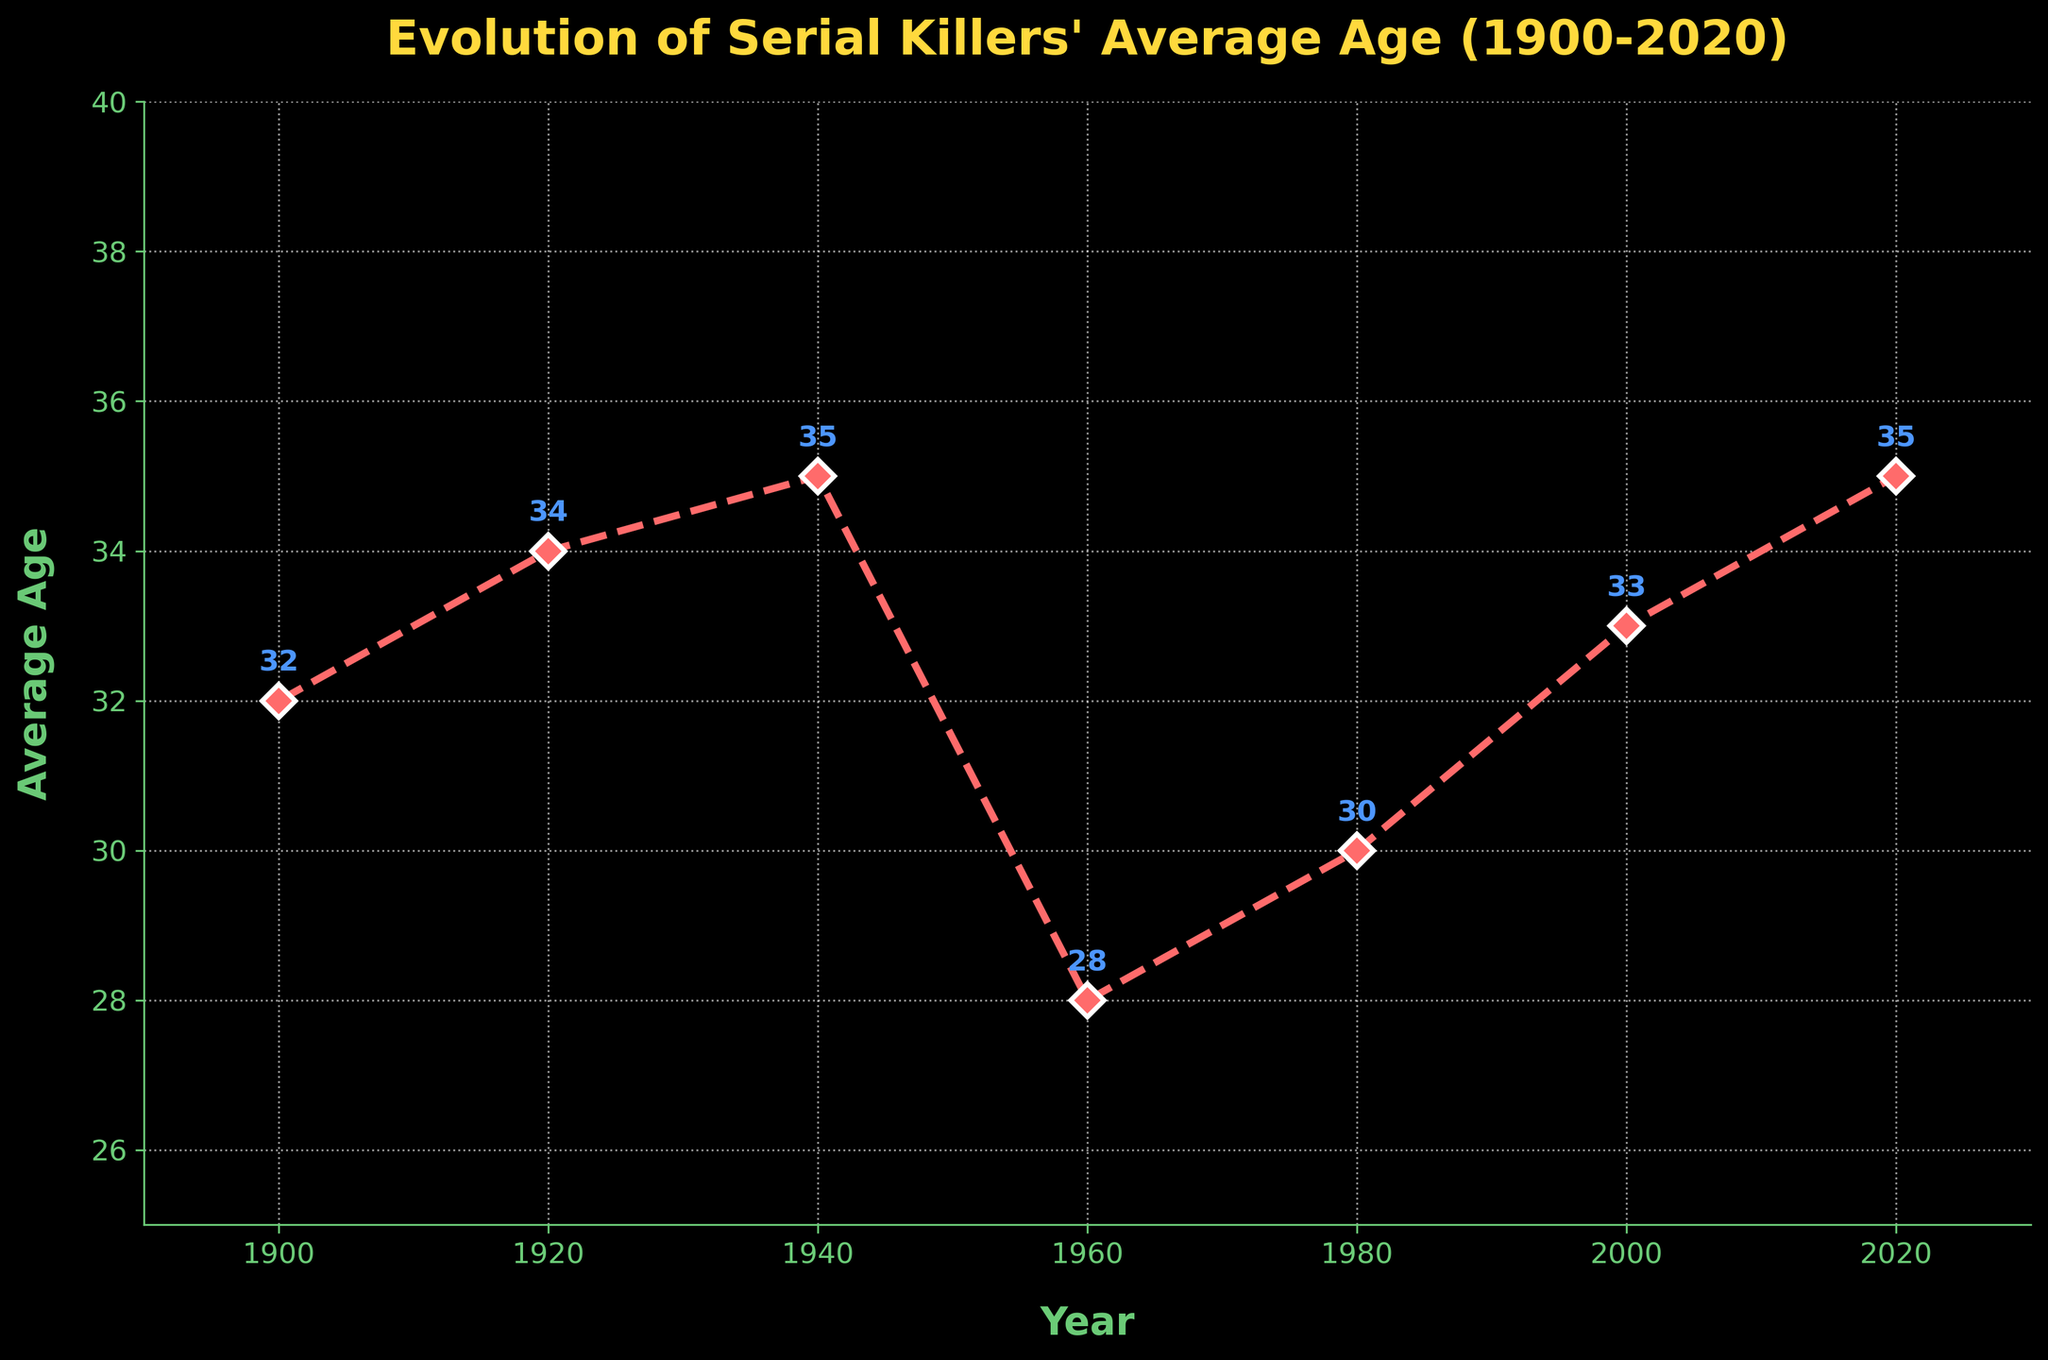What was the average age of serial killers in 1960? Looking at the year "1960" on the x-axis and finding the corresponding point on the line will provide the average age. The point is labeled with the age.
Answer: 28 What is the difference in the average age of serial killers between 1980 and 2020? First, locate the points for 1980 and 2020 on the x-axis and find their corresponding average ages, which are 30 and 35 respectively. Then, subtract the average age in 1980 from that in 2020 (35 - 30).
Answer: 5 Which decade showed the lowest average age of serial killers? Observing the line chart, the lowest point corresponds to the year 1960. To translate this to a decade, note that the data point for the lowest average age is in the 1960s.
Answer: 1960s Is there any period where the average age remained the same for two consecutive data points? By comparing adjacent points on the line chart, note that from 1940 to 1960, the average age did not remain the same. Similarly, from 1960 to 1980, etc. Only from 2000 to 2020 is the average age equal, showing 35 in both years.
Answer: 2000 to 2020 By how much did the average age increase from 1900 to 1940? The average age in 1900 was 32, and in 1940 it was 35. The increase is calculated as (35 - 32).
Answer: 3 During which 20-year span did the average age decrease the most? Check the differences in average ages between each 20-year interval. The intervals are: 1900-1920 (34 - 32 = 2), 1920-1940 (35 - 34 = 1), 1940-1960 (28 - 35 = -7), and so on. The largest decrease occurred from 1940 to 1960 with a drop of -7.
Answer: 1940 to 1960 What visual indicator is used to mark each data point on the line chart? Observe the type of marker used to denote each data point along the line. Each data point is marked with a "D" shaped marker.
Answer: D-shaped markers Considering changes over the entire period, was there a general trend in the average age of serial killers? Based on the line plot, observe the overall pattern: early increase (1900 to 1940), a sharp decline (1940 to 1960), and followed by an overall gradual increase.
Answer: Initial increase, significant drop, gradual increase 